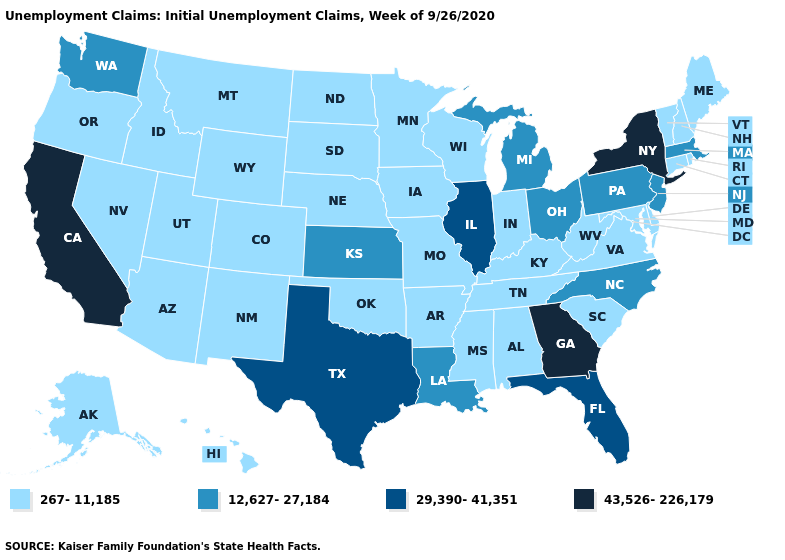Which states have the lowest value in the Northeast?
Short answer required. Connecticut, Maine, New Hampshire, Rhode Island, Vermont. What is the lowest value in states that border Florida?
Write a very short answer. 267-11,185. What is the value of North Carolina?
Write a very short answer. 12,627-27,184. Among the states that border New Jersey , does Pennsylvania have the lowest value?
Give a very brief answer. No. Name the states that have a value in the range 12,627-27,184?
Write a very short answer. Kansas, Louisiana, Massachusetts, Michigan, New Jersey, North Carolina, Ohio, Pennsylvania, Washington. What is the lowest value in states that border Colorado?
Give a very brief answer. 267-11,185. Name the states that have a value in the range 12,627-27,184?
Quick response, please. Kansas, Louisiana, Massachusetts, Michigan, New Jersey, North Carolina, Ohio, Pennsylvania, Washington. What is the highest value in the USA?
Write a very short answer. 43,526-226,179. Does Massachusetts have the lowest value in the USA?
Quick response, please. No. What is the value of Mississippi?
Concise answer only. 267-11,185. Does Louisiana have a higher value than Florida?
Be succinct. No. Does New York have the same value as Tennessee?
Quick response, please. No. What is the value of Iowa?
Answer briefly. 267-11,185. What is the value of Indiana?
Keep it brief. 267-11,185. What is the highest value in states that border North Carolina?
Give a very brief answer. 43,526-226,179. 